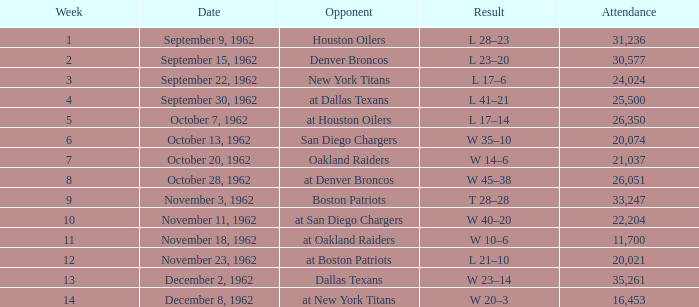What week was the attendance smaller than 22,204 on December 8, 1962? 14.0. 